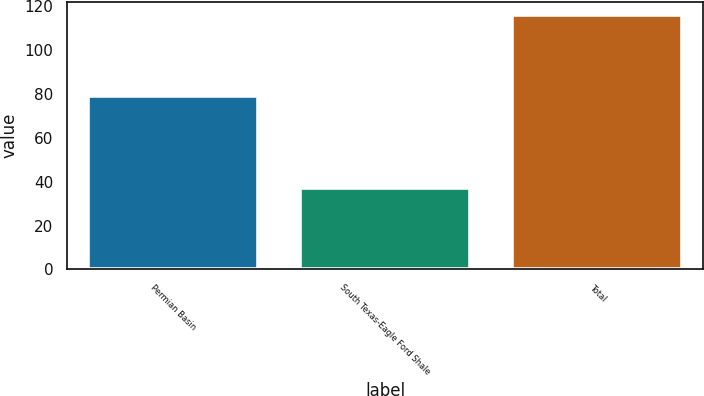Convert chart. <chart><loc_0><loc_0><loc_500><loc_500><bar_chart><fcel>Permian Basin<fcel>South Texas-Eagle Ford Shale<fcel>Total<nl><fcel>79<fcel>37<fcel>116<nl></chart> 